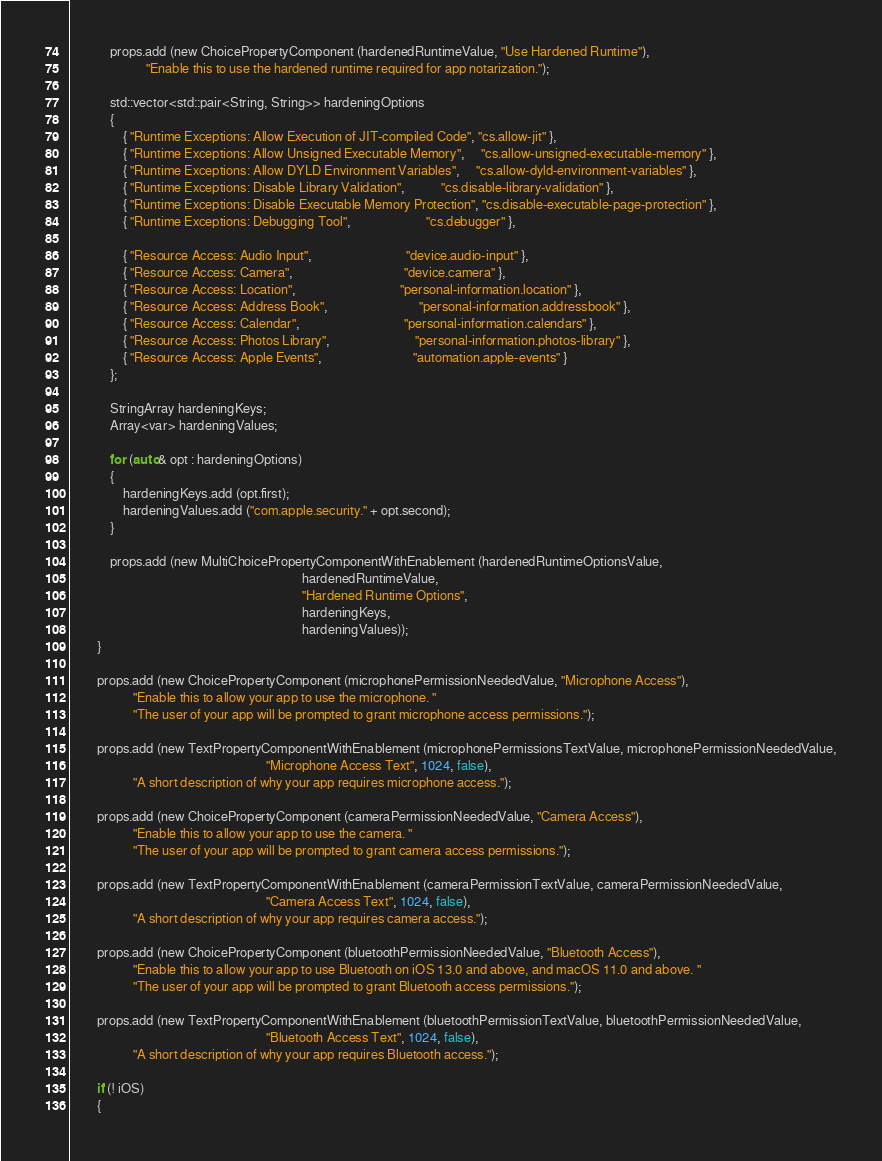<code> <loc_0><loc_0><loc_500><loc_500><_C_>            props.add (new ChoicePropertyComponent (hardenedRuntimeValue, "Use Hardened Runtime"),
                       "Enable this to use the hardened runtime required for app notarization.");

            std::vector<std::pair<String, String>> hardeningOptions
            {
                { "Runtime Exceptions: Allow Execution of JIT-compiled Code", "cs.allow-jit" },
                { "Runtime Exceptions: Allow Unsigned Executable Memory",     "cs.allow-unsigned-executable-memory" },
                { "Runtime Exceptions: Allow DYLD Environment Variables",     "cs.allow-dyld-environment-variables" },
                { "Runtime Exceptions: Disable Library Validation",           "cs.disable-library-validation" },
                { "Runtime Exceptions: Disable Executable Memory Protection", "cs.disable-executable-page-protection" },
                { "Runtime Exceptions: Debugging Tool",                       "cs.debugger" },

                { "Resource Access: Audio Input",                             "device.audio-input" },
                { "Resource Access: Camera",                                  "device.camera" },
                { "Resource Access: Location",                                "personal-information.location" },
                { "Resource Access: Address Book",                            "personal-information.addressbook" },
                { "Resource Access: Calendar",                                "personal-information.calendars" },
                { "Resource Access: Photos Library",                          "personal-information.photos-library" },
                { "Resource Access: Apple Events",                            "automation.apple-events" }
            };

            StringArray hardeningKeys;
            Array<var> hardeningValues;

            for (auto& opt : hardeningOptions)
            {
                hardeningKeys.add (opt.first);
                hardeningValues.add ("com.apple.security." + opt.second);
            }

            props.add (new MultiChoicePropertyComponentWithEnablement (hardenedRuntimeOptionsValue,
                                                                       hardenedRuntimeValue,
                                                                       "Hardened Runtime Options",
                                                                       hardeningKeys,
                                                                       hardeningValues));
        }

        props.add (new ChoicePropertyComponent (microphonePermissionNeededValue, "Microphone Access"),
                   "Enable this to allow your app to use the microphone. "
                   "The user of your app will be prompted to grant microphone access permissions.");

        props.add (new TextPropertyComponentWithEnablement (microphonePermissionsTextValue, microphonePermissionNeededValue,
                                                            "Microphone Access Text", 1024, false),
                   "A short description of why your app requires microphone access.");

        props.add (new ChoicePropertyComponent (cameraPermissionNeededValue, "Camera Access"),
                   "Enable this to allow your app to use the camera. "
                   "The user of your app will be prompted to grant camera access permissions.");

        props.add (new TextPropertyComponentWithEnablement (cameraPermissionTextValue, cameraPermissionNeededValue,
                                                            "Camera Access Text", 1024, false),
                   "A short description of why your app requires camera access.");

        props.add (new ChoicePropertyComponent (bluetoothPermissionNeededValue, "Bluetooth Access"),
                   "Enable this to allow your app to use Bluetooth on iOS 13.0 and above, and macOS 11.0 and above. "
                   "The user of your app will be prompted to grant Bluetooth access permissions.");

        props.add (new TextPropertyComponentWithEnablement (bluetoothPermissionTextValue, bluetoothPermissionNeededValue,
                                                            "Bluetooth Access Text", 1024, false),
                   "A short description of why your app requires Bluetooth access.");

        if (! iOS)
        {</code> 